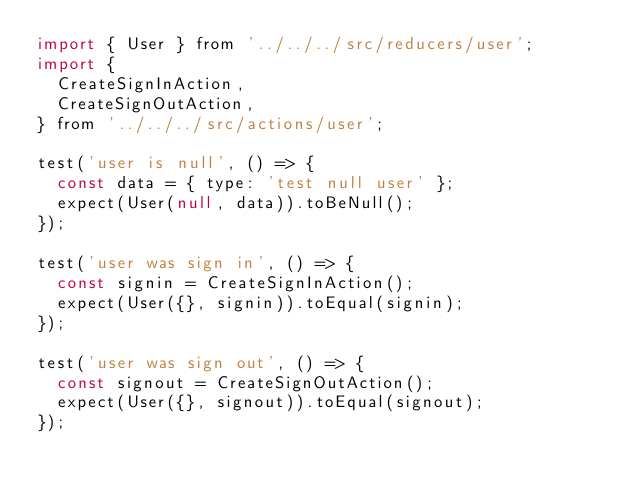<code> <loc_0><loc_0><loc_500><loc_500><_JavaScript_>import { User } from '../../../src/reducers/user';
import {
  CreateSignInAction,
  CreateSignOutAction,
} from '../../../src/actions/user';

test('user is null', () => {
  const data = { type: 'test null user' };
  expect(User(null, data)).toBeNull();
});

test('user was sign in', () => {
  const signin = CreateSignInAction();
  expect(User({}, signin)).toEqual(signin);
});

test('user was sign out', () => {
  const signout = CreateSignOutAction();
  expect(User({}, signout)).toEqual(signout);
});
</code> 